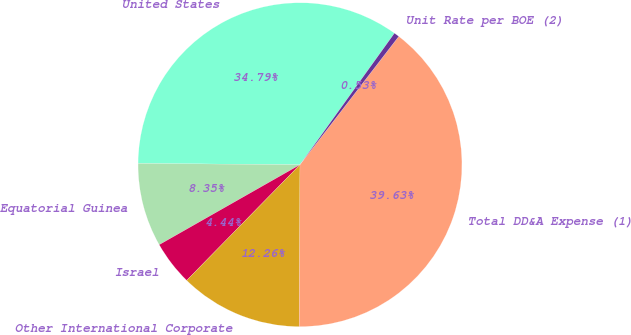Convert chart. <chart><loc_0><loc_0><loc_500><loc_500><pie_chart><fcel>United States<fcel>Equatorial Guinea<fcel>Israel<fcel>Other International Corporate<fcel>Total DD&A Expense (1)<fcel>Unit Rate per BOE (2)<nl><fcel>34.79%<fcel>8.35%<fcel>4.44%<fcel>12.26%<fcel>39.63%<fcel>0.53%<nl></chart> 